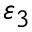Convert formula to latex. <formula><loc_0><loc_0><loc_500><loc_500>\varepsilon _ { 3 }</formula> 